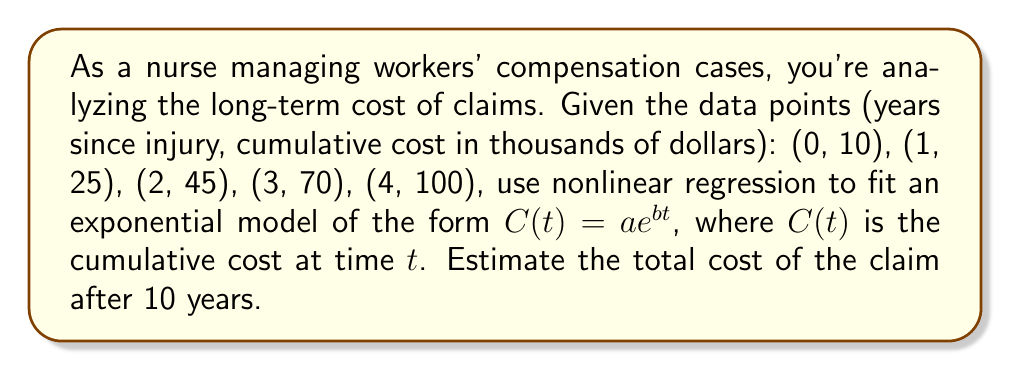Provide a solution to this math problem. 1) We'll use the exponential model $C(t) = ae^{bt}$, where $a$ and $b$ are parameters to be estimated.

2) To linearize this model, take the natural logarithm of both sides:
   $\ln(C(t)) = \ln(a) + bt$

3) Let $y = \ln(C(t))$ and $x = t$. We now have a linear equation $y = \ln(a) + bx$

4) Using the given data points, create a new set of points $(x, y)$:
   (0, ln(10)), (1, ln(25)), (2, ln(45)), (3, ln(70)), (4, ln(100))

5) Use linear regression to find the best-fit line $y = mx + c$, where $m = b$ and $c = \ln(a)$

6) The resulting line equation (approximate values):
   $y = 0.5878x + 2.3979$

7) Therefore, $b = 0.5878$ and $\ln(a) = 2.3979$

8) Solving for $a$: $a = e^{2.3979} \approx 11.0011$

9) Our nonlinear regression model is:
   $C(t) = 11.0011e^{0.5878t}$

10) To estimate the cost after 10 years, substitute $t = 10$:
    $C(10) = 11.0011e^{0.5878 \cdot 10} \approx 422.6865$

11) The estimated cost after 10 years is approximately $422,686.50
Answer: $422,686.50 